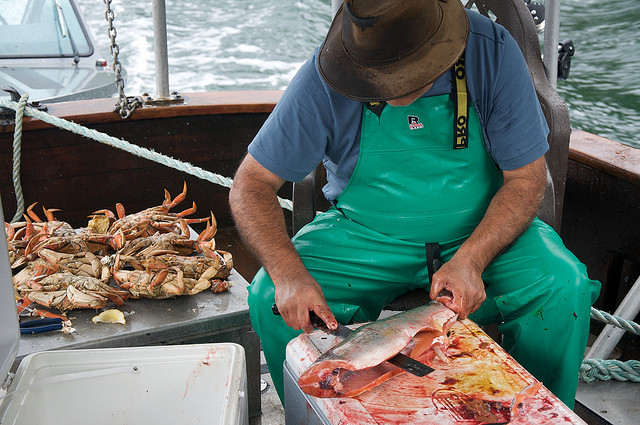Identify the text contained in this image. 8 bbo 